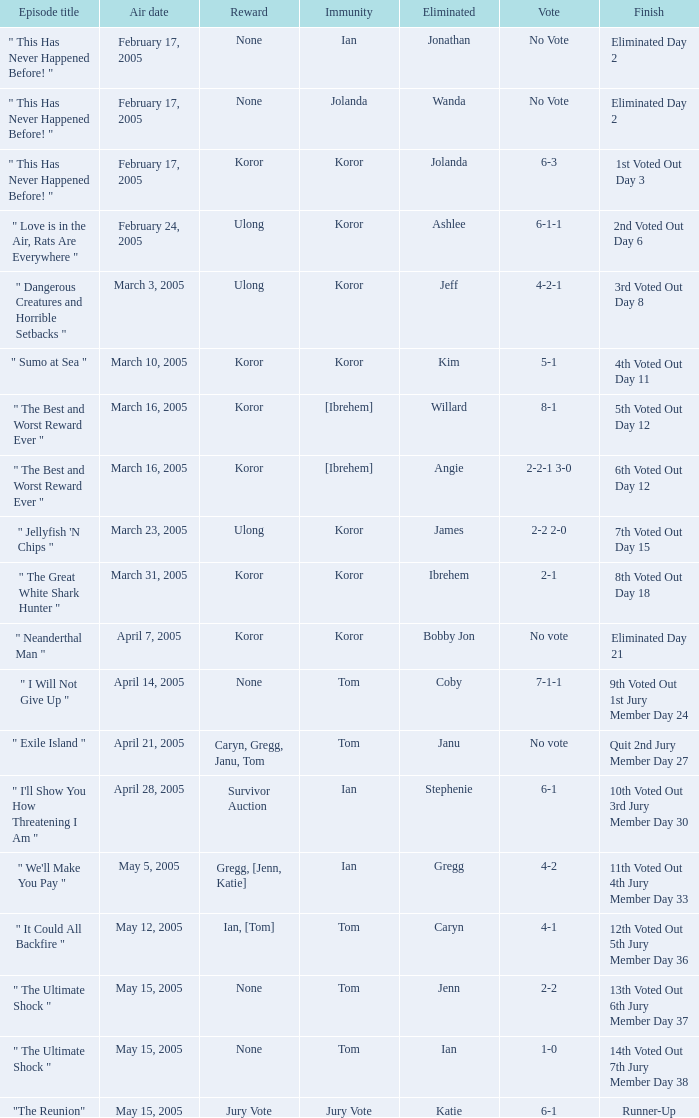In which episode is jenn's elimination named? " The Ultimate Shock ". 